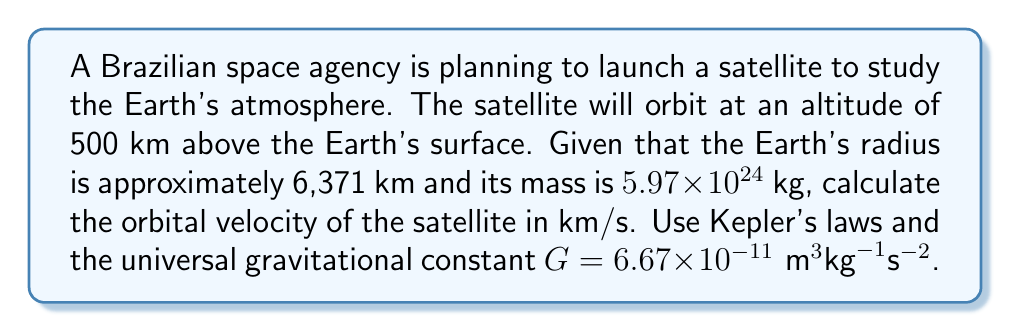Provide a solution to this math problem. To solve this problem, we'll use Kepler's third law in combination with Newton's law of universal gravitation. Here's a step-by-step approach:

1) First, we need to calculate the radius of the orbit. This is the sum of Earth's radius and the satellite's altitude:
   $r = 6371 \text{ km} + 500 \text{ km} = 6871 \text{ km} = 6.871 \times 10^6 \text{ m}$

2) Kepler's third law states that the square of the orbital period is proportional to the cube of the semi-major axis. For circular orbits, this can be expressed as:

   $$T^2 = \frac{4\pi^2}{GM}r^3$$

   where $T$ is the orbital period, $G$ is the gravitational constant, $M$ is the mass of Earth, and $r$ is the orbital radius.

3) We can rearrange this to find the orbital velocity $v$, knowing that for circular orbits, $v = \frac{2\pi r}{T}$:

   $$v^2 = \frac{GM}{r}$$

4) Now we can substitute the known values:

   $$v^2 = \frac{(6.67 \times 10^{-11})(5.97 \times 10^{24})}{6.871 \times 10^6}$$

5) Simplify:
   
   $$v^2 = 5.7924 \times 10^7$$

6) Take the square root of both sides:

   $$v = \sqrt{5.7924 \times 10^7} = 7610.68 \text{ m/s}$$

7) Convert to km/s:

   $$v = 7.61068 \text{ km/s}$$
Answer: The orbital velocity of the satellite is approximately 7.61 km/s. 